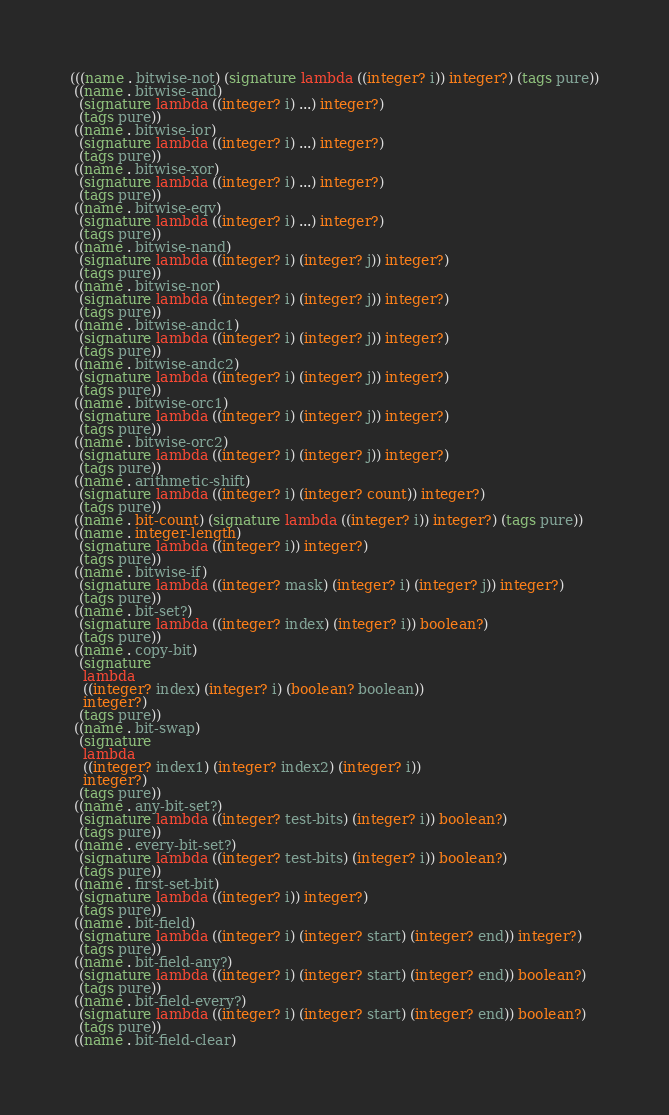Convert code to text. <code><loc_0><loc_0><loc_500><loc_500><_Scheme_>(((name . bitwise-not) (signature lambda ((integer? i)) integer?) (tags pure))
 ((name . bitwise-and)
  (signature lambda ((integer? i) ...) integer?)
  (tags pure))
 ((name . bitwise-ior)
  (signature lambda ((integer? i) ...) integer?)
  (tags pure))
 ((name . bitwise-xor)
  (signature lambda ((integer? i) ...) integer?)
  (tags pure))
 ((name . bitwise-eqv)
  (signature lambda ((integer? i) ...) integer?)
  (tags pure))
 ((name . bitwise-nand)
  (signature lambda ((integer? i) (integer? j)) integer?)
  (tags pure))
 ((name . bitwise-nor)
  (signature lambda ((integer? i) (integer? j)) integer?)
  (tags pure))
 ((name . bitwise-andc1)
  (signature lambda ((integer? i) (integer? j)) integer?)
  (tags pure))
 ((name . bitwise-andc2)
  (signature lambda ((integer? i) (integer? j)) integer?)
  (tags pure))
 ((name . bitwise-orc1)
  (signature lambda ((integer? i) (integer? j)) integer?)
  (tags pure))
 ((name . bitwise-orc2)
  (signature lambda ((integer? i) (integer? j)) integer?)
  (tags pure))
 ((name . arithmetic-shift)
  (signature lambda ((integer? i) (integer? count)) integer?)
  (tags pure))
 ((name . bit-count) (signature lambda ((integer? i)) integer?) (tags pure))
 ((name . integer-length)
  (signature lambda ((integer? i)) integer?)
  (tags pure))
 ((name . bitwise-if)
  (signature lambda ((integer? mask) (integer? i) (integer? j)) integer?)
  (tags pure))
 ((name . bit-set?)
  (signature lambda ((integer? index) (integer? i)) boolean?)
  (tags pure))
 ((name . copy-bit)
  (signature
   lambda
   ((integer? index) (integer? i) (boolean? boolean))
   integer?)
  (tags pure))
 ((name . bit-swap)
  (signature
   lambda
   ((integer? index1) (integer? index2) (integer? i))
   integer?)
  (tags pure))
 ((name . any-bit-set?)
  (signature lambda ((integer? test-bits) (integer? i)) boolean?)
  (tags pure))
 ((name . every-bit-set?)
  (signature lambda ((integer? test-bits) (integer? i)) boolean?)
  (tags pure))
 ((name . first-set-bit)
  (signature lambda ((integer? i)) integer?)
  (tags pure))
 ((name . bit-field)
  (signature lambda ((integer? i) (integer? start) (integer? end)) integer?)
  (tags pure))
 ((name . bit-field-any?)
  (signature lambda ((integer? i) (integer? start) (integer? end)) boolean?)
  (tags pure))
 ((name . bit-field-every?)
  (signature lambda ((integer? i) (integer? start) (integer? end)) boolean?)
  (tags pure))
 ((name . bit-field-clear)</code> 